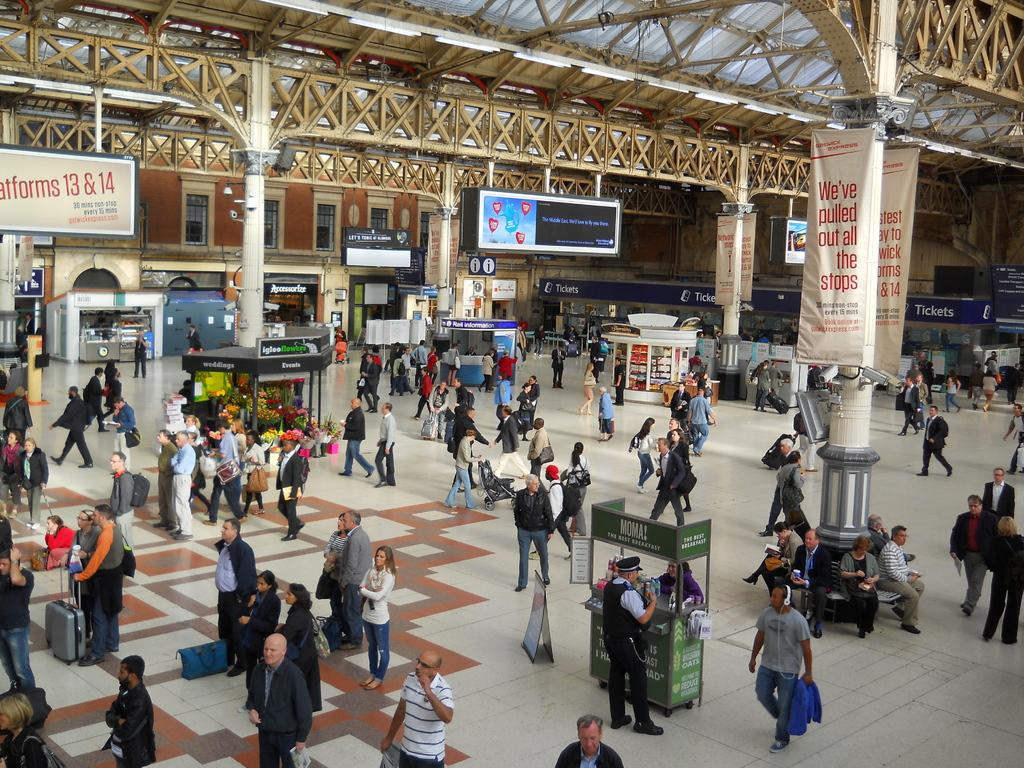<image>
Write a terse but informative summary of the picture. Train station or airport that has a sign displayed that says "We've Pulled Out All The Stops" 